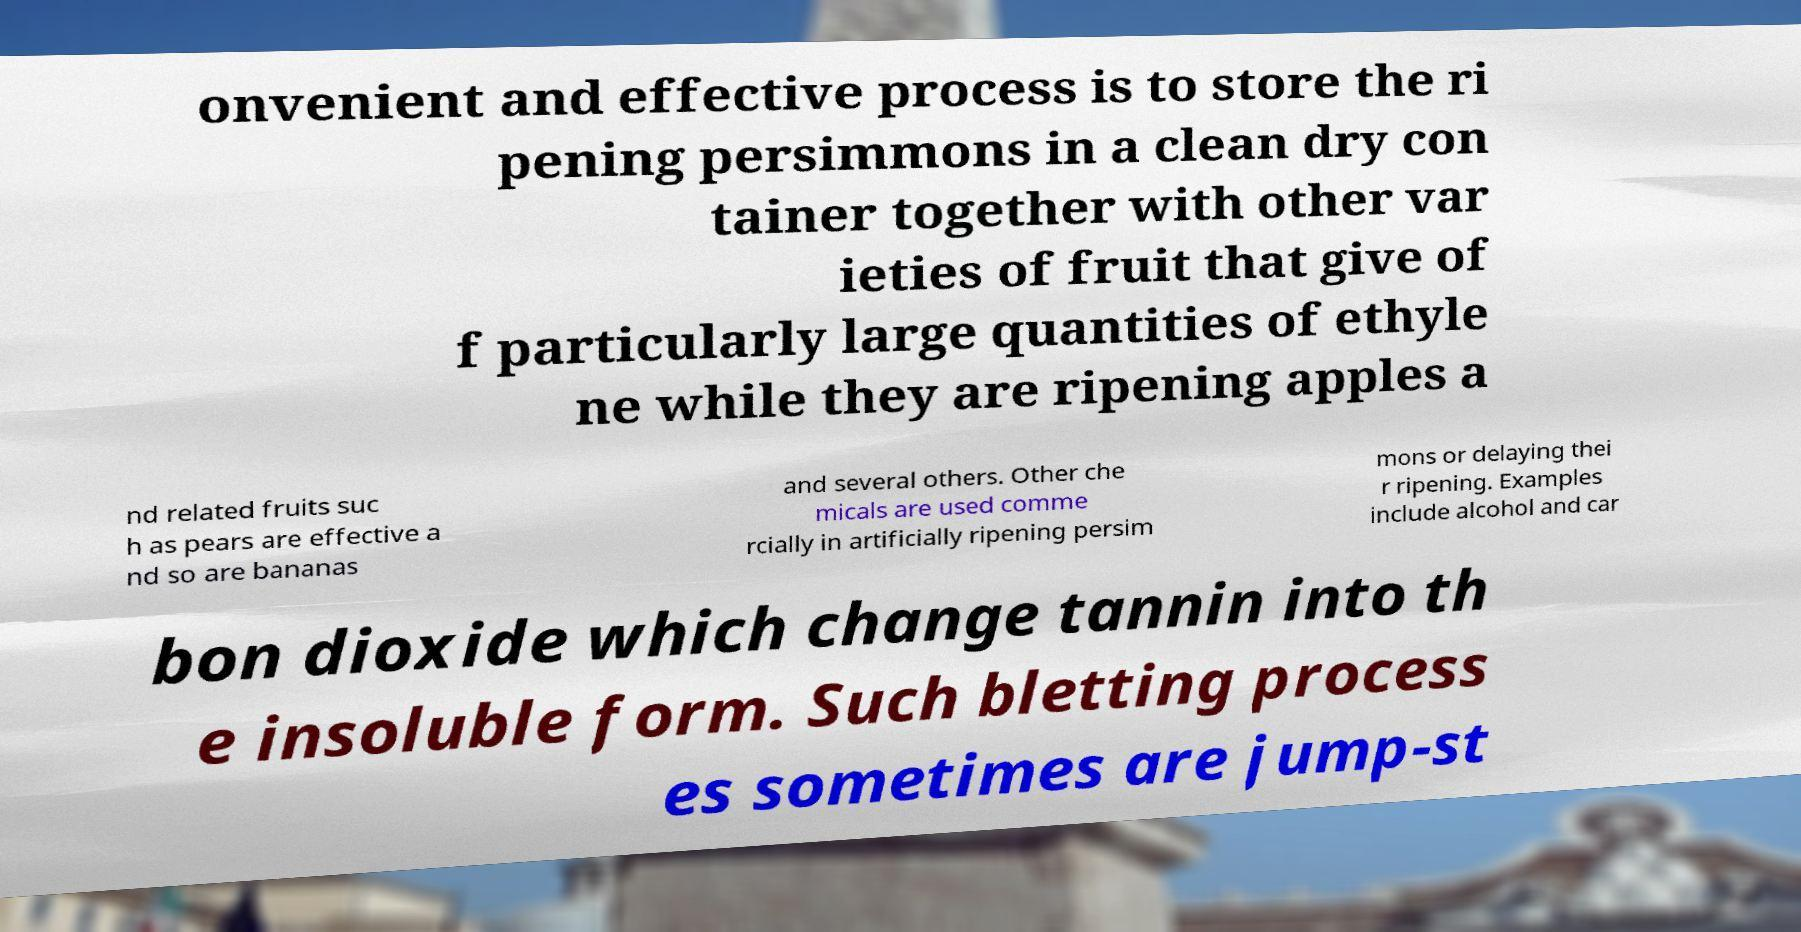Can you read and provide the text displayed in the image?This photo seems to have some interesting text. Can you extract and type it out for me? onvenient and effective process is to store the ri pening persimmons in a clean dry con tainer together with other var ieties of fruit that give of f particularly large quantities of ethyle ne while they are ripening apples a nd related fruits suc h as pears are effective a nd so are bananas and several others. Other che micals are used comme rcially in artificially ripening persim mons or delaying thei r ripening. Examples include alcohol and car bon dioxide which change tannin into th e insoluble form. Such bletting process es sometimes are jump-st 